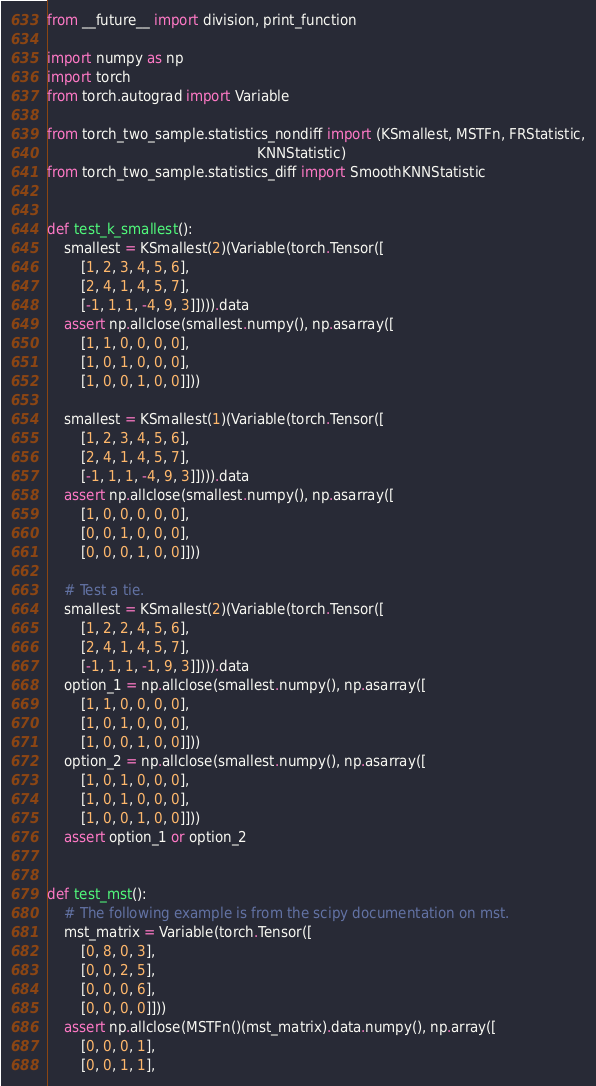Convert code to text. <code><loc_0><loc_0><loc_500><loc_500><_Python_>from __future__ import division, print_function

import numpy as np
import torch
from torch.autograd import Variable

from torch_two_sample.statistics_nondiff import (KSmallest, MSTFn, FRStatistic,
                                                 KNNStatistic)
from torch_two_sample.statistics_diff import SmoothKNNStatistic


def test_k_smallest():
    smallest = KSmallest(2)(Variable(torch.Tensor([
        [1, 2, 3, 4, 5, 6],
        [2, 4, 1, 4, 5, 7],
        [-1, 1, 1, -4, 9, 3]]))).data
    assert np.allclose(smallest.numpy(), np.asarray([
        [1, 1, 0, 0, 0, 0],
        [1, 0, 1, 0, 0, 0],
        [1, 0, 0, 1, 0, 0]]))

    smallest = KSmallest(1)(Variable(torch.Tensor([
        [1, 2, 3, 4, 5, 6],
        [2, 4, 1, 4, 5, 7],
        [-1, 1, 1, -4, 9, 3]]))).data
    assert np.allclose(smallest.numpy(), np.asarray([
        [1, 0, 0, 0, 0, 0],
        [0, 0, 1, 0, 0, 0],
        [0, 0, 0, 1, 0, 0]]))

    # Test a tie.
    smallest = KSmallest(2)(Variable(torch.Tensor([
        [1, 2, 2, 4, 5, 6],
        [2, 4, 1, 4, 5, 7],
        [-1, 1, 1, -1, 9, 3]]))).data
    option_1 = np.allclose(smallest.numpy(), np.asarray([
        [1, 1, 0, 0, 0, 0],
        [1, 0, 1, 0, 0, 0],
        [1, 0, 0, 1, 0, 0]]))
    option_2 = np.allclose(smallest.numpy(), np.asarray([
        [1, 0, 1, 0, 0, 0],
        [1, 0, 1, 0, 0, 0],
        [1, 0, 0, 1, 0, 0]]))
    assert option_1 or option_2


def test_mst():
    # The following example is from the scipy documentation on mst.
    mst_matrix = Variable(torch.Tensor([
        [0, 8, 0, 3],
        [0, 0, 2, 5],
        [0, 0, 0, 6],
        [0, 0, 0, 0]]))
    assert np.allclose(MSTFn()(mst_matrix).data.numpy(), np.array([
        [0, 0, 0, 1],
        [0, 0, 1, 1],</code> 